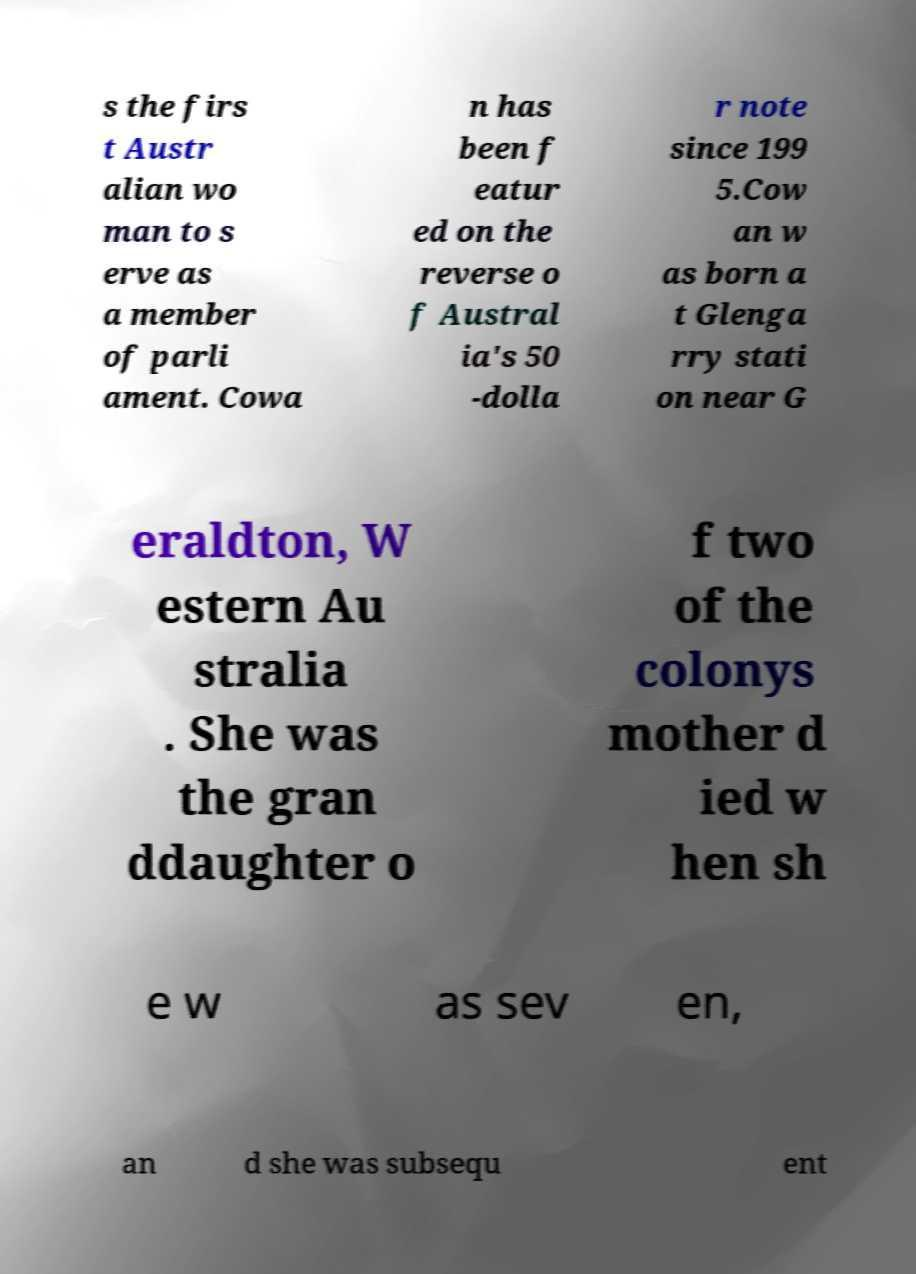There's text embedded in this image that I need extracted. Can you transcribe it verbatim? s the firs t Austr alian wo man to s erve as a member of parli ament. Cowa n has been f eatur ed on the reverse o f Austral ia's 50 -dolla r note since 199 5.Cow an w as born a t Glenga rry stati on near G eraldton, W estern Au stralia . She was the gran ddaughter o f two of the colonys mother d ied w hen sh e w as sev en, an d she was subsequ ent 